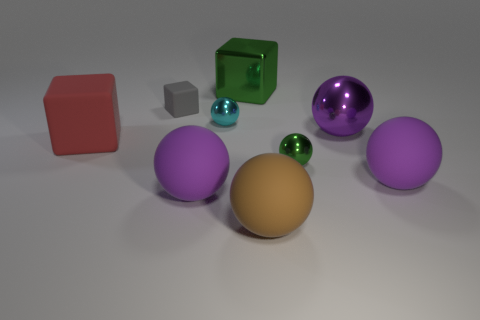How many purple balls must be subtracted to get 1 purple balls? 2 Subtract all purple cubes. How many purple balls are left? 3 Subtract all cyan balls. How many balls are left? 5 Subtract all small green metal spheres. How many spheres are left? 5 Subtract all brown spheres. Subtract all gray cylinders. How many spheres are left? 5 Add 1 tiny gray things. How many objects exist? 10 Subtract all cubes. How many objects are left? 6 Subtract 0 cyan blocks. How many objects are left? 9 Subtract all cyan matte cubes. Subtract all tiny gray rubber things. How many objects are left? 8 Add 9 brown rubber balls. How many brown rubber balls are left? 10 